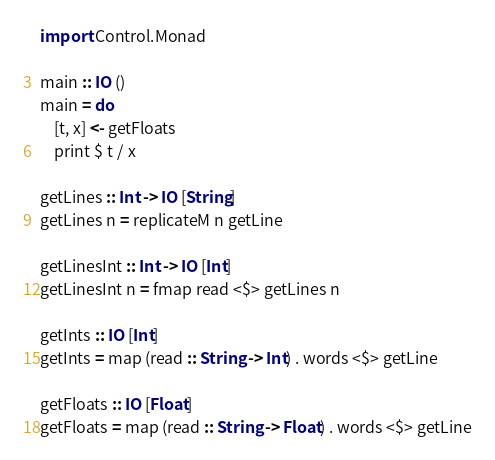Convert code to text. <code><loc_0><loc_0><loc_500><loc_500><_Haskell_>import Control.Monad

main :: IO ()
main = do
    [t, x] <- getFloats
    print $ t / x

getLines :: Int -> IO [String]
getLines n = replicateM n getLine

getLinesInt :: Int -> IO [Int]
getLinesInt n = fmap read <$> getLines n

getInts :: IO [Int]
getInts = map (read :: String -> Int) . words <$> getLine

getFloats :: IO [Float]
getFloats = map (read :: String -> Float) . words <$> getLine</code> 